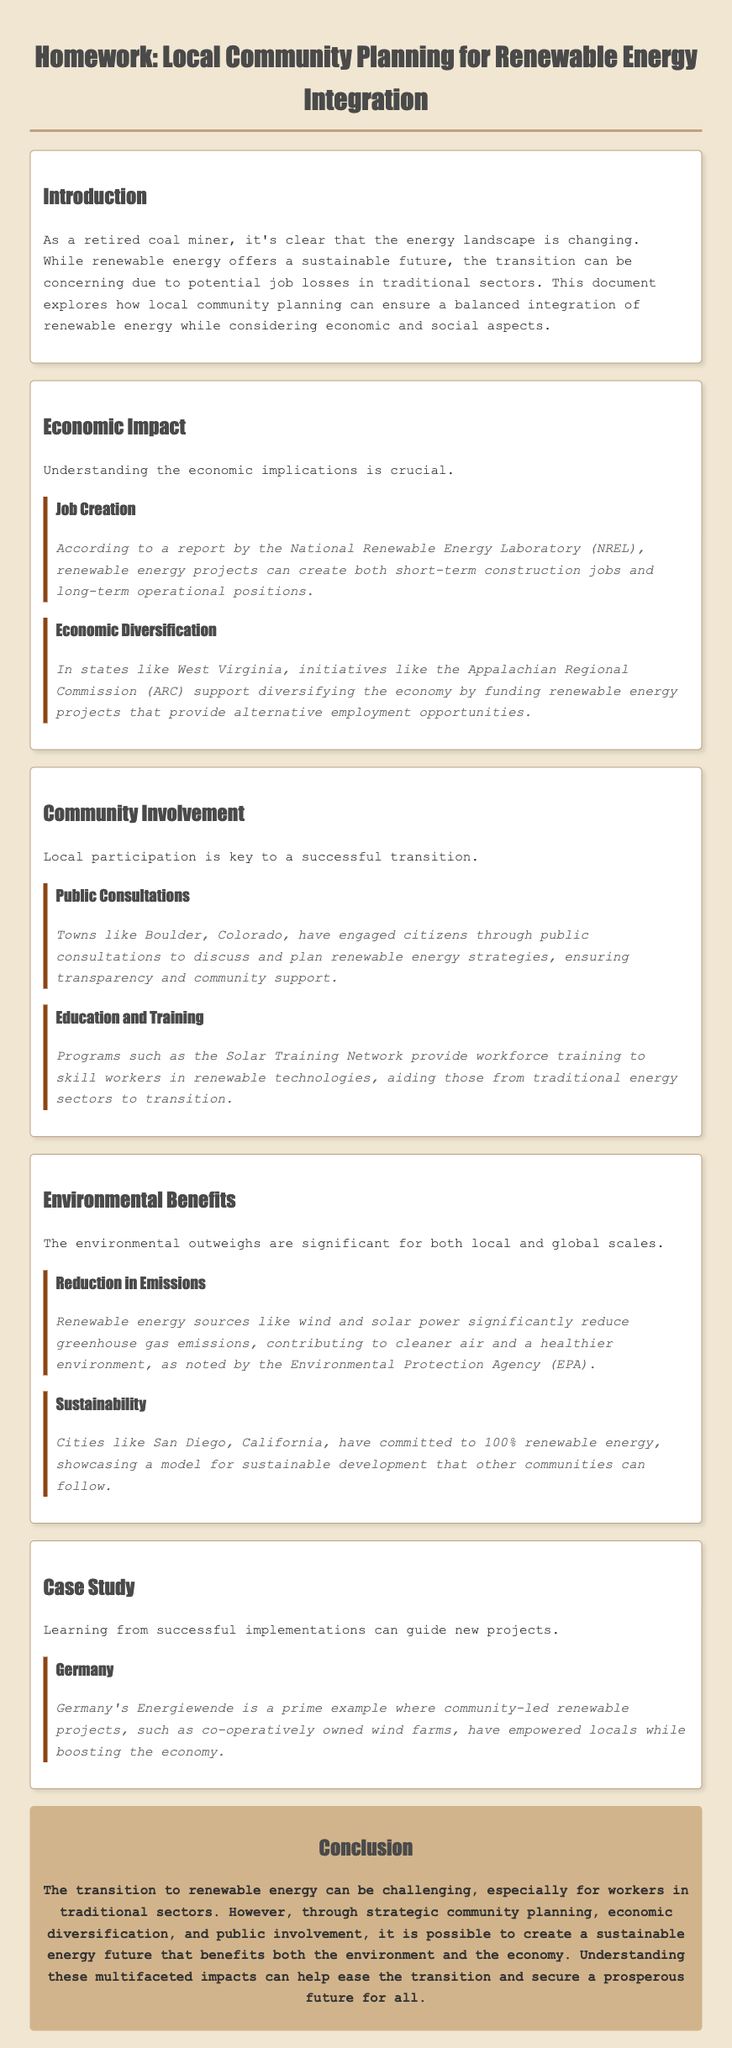what is the title of the homework document? The title of the document is displayed prominently at the top and is "Homework: Local Community Planning for Renewable Energy Integration."
Answer: Homework: Local Community Planning for Renewable Energy Integration what does NREL stand for? NREL is mentioned in the economic impact section, specifically in the context of job creation, and it stands for the National Renewable Energy Laboratory.
Answer: National Renewable Energy Laboratory what is one example of community involvement mentioned? The document cites public consultations in towns like Boulder, Colorado, as an example of community involvement in renewable energy planning.
Answer: public consultations which city is noted for committing to 100% renewable energy? San Diego, California, is specifically mentioned as a city that has committed to 100% renewable energy.
Answer: San Diego what type of jobs do renewable energy projects create? According to the document, renewable energy projects create both short-term construction jobs and long-term operational positions.
Answer: construction jobs and operational positions what key aspect is highlighted as necessary for a successful transition? The document emphasizes local participation as a key aspect necessary for a successful transition to renewable energy.
Answer: local participation what is the focus of the case study in the document? The case study focuses on Germany's Energiewende, which is about community-led renewable projects and their economic empowerment.
Answer: Germany's Energiewende which organization supports economic diversification in states like West Virginia? The Appalachian Regional Commission (ARC) is mentioned as an organization supporting economic diversification in the document.
Answer: Appalachian Regional Commission what is the main environmental benefit cited? A reduction in greenhouse gas emissions is highlighted as the main environmental benefit of renewable energy sources.
Answer: reduction in emissions 